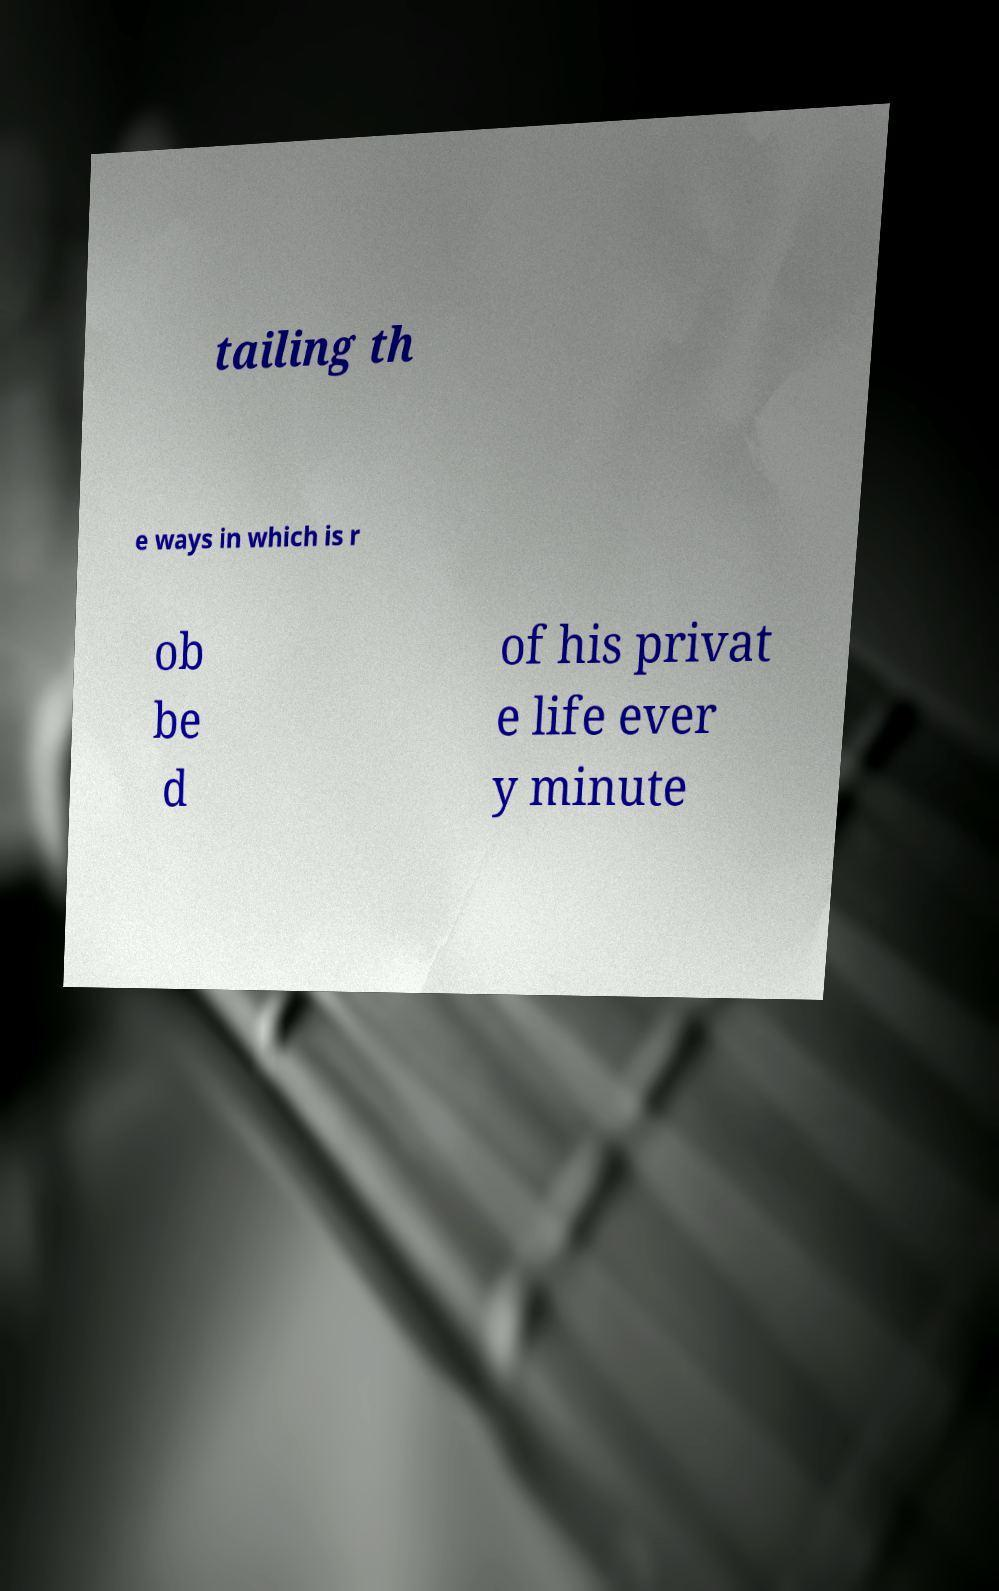Can you accurately transcribe the text from the provided image for me? tailing th e ways in which is r ob be d of his privat e life ever y minute 